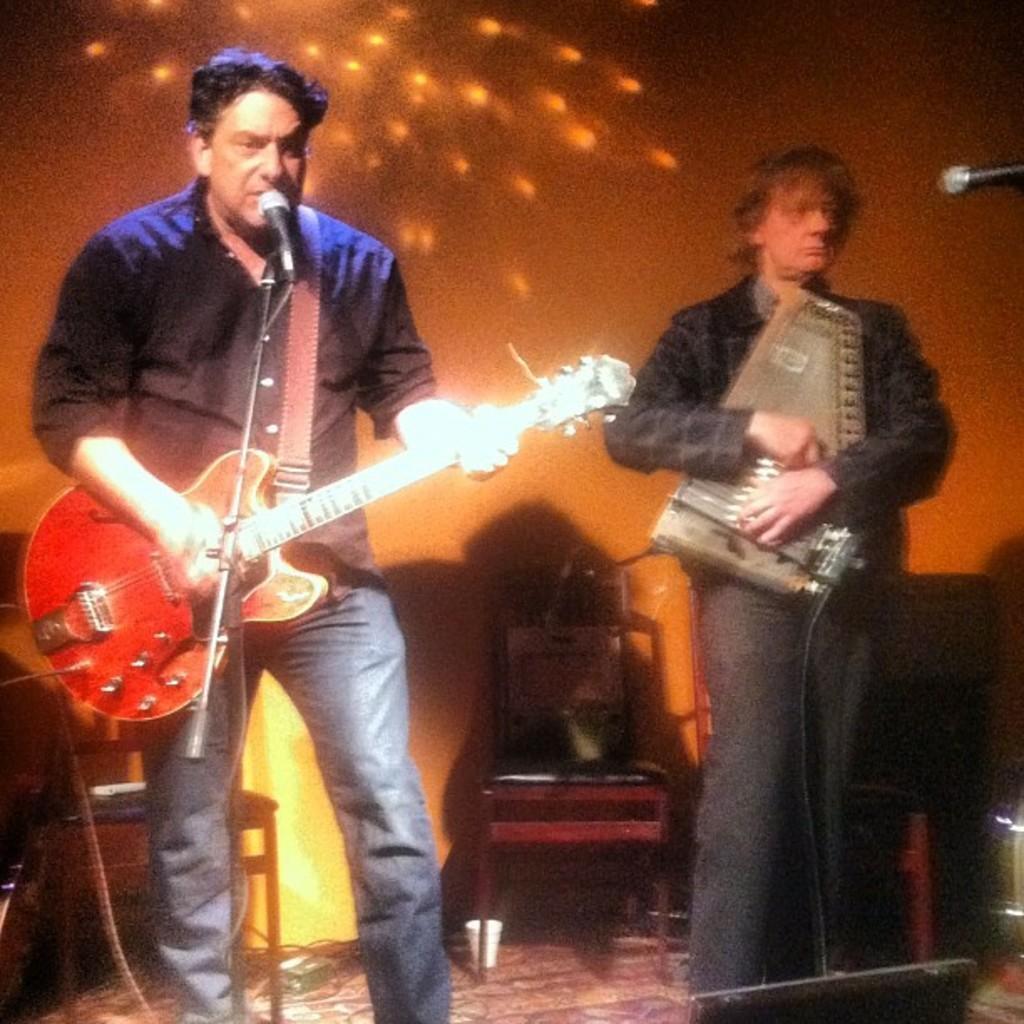Please provide a concise description of this image. The person wearing blue jeans is playing guitar and singing in front of a mic and the person beside him is playing some musical instrument. 